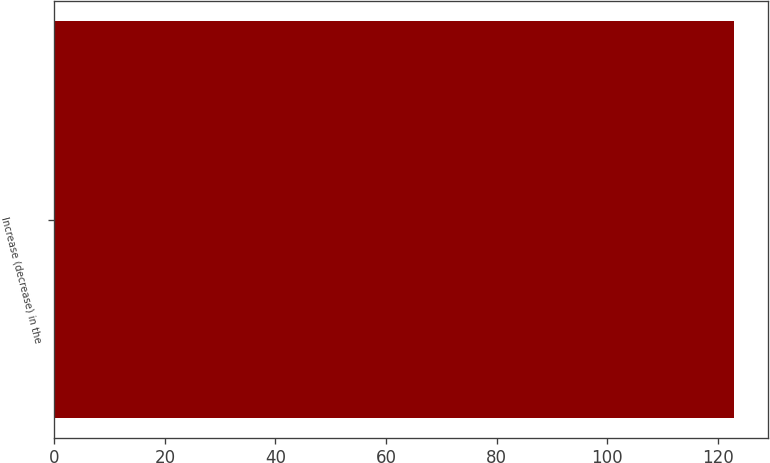<chart> <loc_0><loc_0><loc_500><loc_500><bar_chart><fcel>Increase (decrease) in the<nl><fcel>123<nl></chart> 